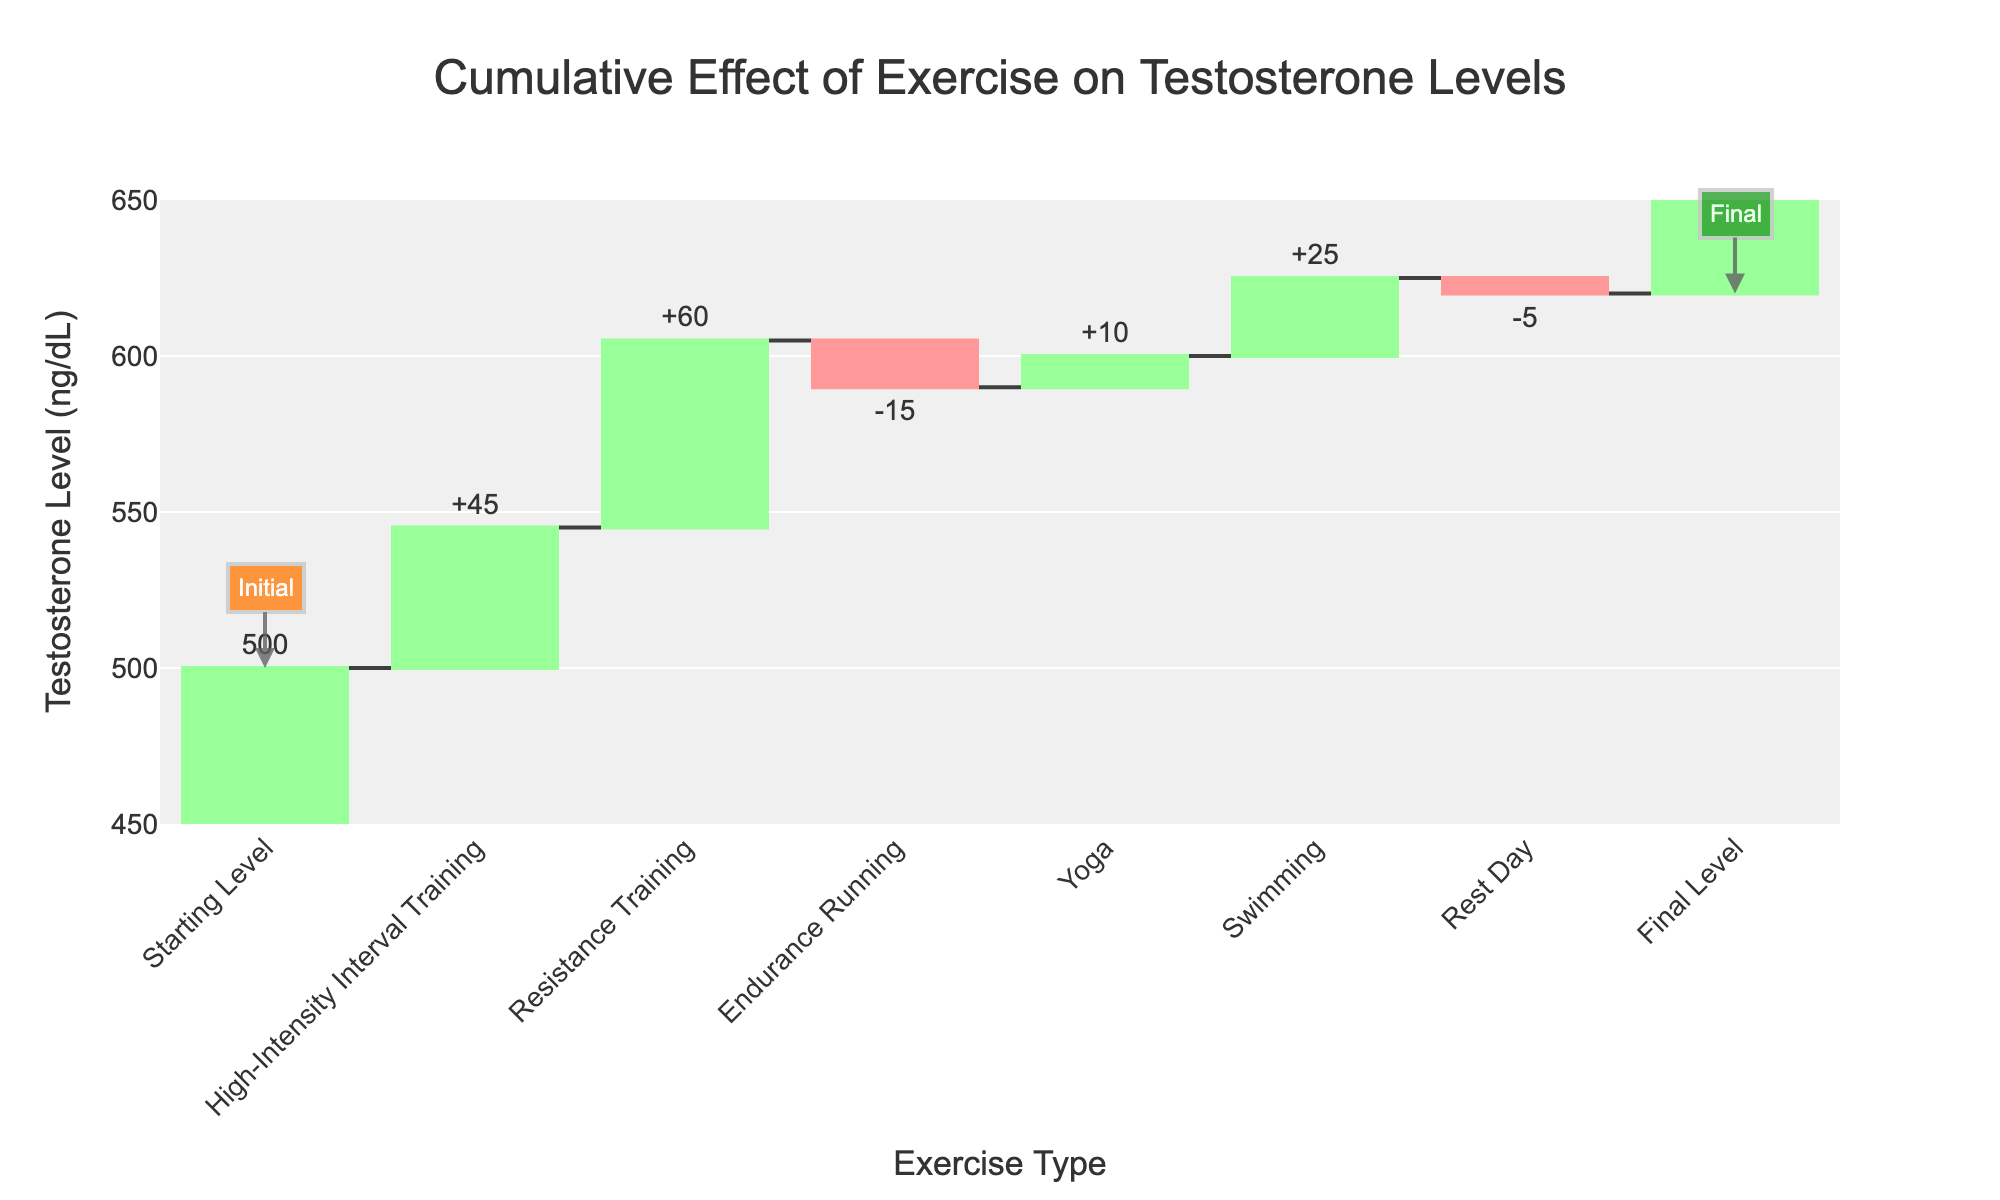What is the title of the figure? The title of the figure is typically displayed prominently at the top and provides an overview of what the chart represents.
Answer: "Cumulative Effect of Exercise on Testosterone Levels" How much does testosterone increase due to Resistance Training? The value for Resistance Training is represented as a positive change in the waterfall chart. By looking at the increase labeled near the Resistance Training bar, we can see the exact value.
Answer: +60 ng/dL What is the final testosterone level after all exercises and activities over the week? The final level is shown at the end of the waterfall chart under "Final Level." This is the cumulative result of all changes applied to the initial value.
Answer: 620 ng/dL Which exercise type results in the largest increase in testosterone levels? By examining the individual increases, we see which bar has the largest positive change. Here, we compare the positive bars.
Answer: Resistance Training What is the net change in testosterone from Endurance Running and Yoga combined? Combining the changes from Endurance Running and Yoga requires summing their values: -15 (Endurance Running) + 10 (Yoga) = -5.
Answer: -5 ng/dL How does the testosterone change from High-Intensity Interval Training compare to Swimming? Comparing the increase in testosterone, we see High-Intensity Interval Training has +45 and Swimming has +25, making high-intensity interval training have a greater increase.
Answer: High-Intensity Interval Training is +20 ng/dL higher than Swimming What is the total increase in testosterone from all exercises combined, excluding the rest day? Summing up the increases and decreases from all exercises (excluding the rest day): +45 (HIIT) + 60 (Resistance) - 15 (Endurance) + 10 (Yoga) + 25 (Swimming) = +125.
Answer: +125 ng/dL What are the starting and ending testosterone levels? The starting and final levels are indicated at the beginning and end of the waterfall chart.
Answer: Starting: 500 ng/dL, Ending: 620 ng/dL What would be the final testosterone level if there were no rest day? Subtract the effect of the rest day from the final testosterone level: 620 ng/dL - (-5 ng/dL) = 625 ng/dL.
Answer: 625 ng/dL 